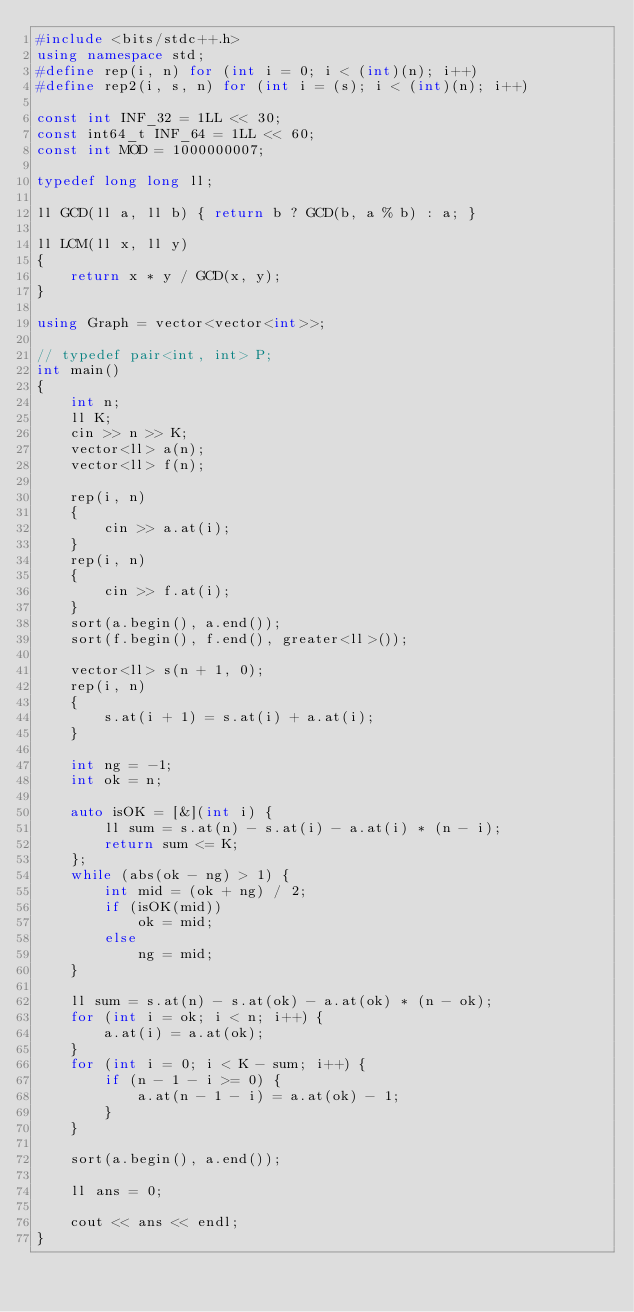Convert code to text. <code><loc_0><loc_0><loc_500><loc_500><_C++_>#include <bits/stdc++.h>
using namespace std;
#define rep(i, n) for (int i = 0; i < (int)(n); i++)
#define rep2(i, s, n) for (int i = (s); i < (int)(n); i++)

const int INF_32 = 1LL << 30;
const int64_t INF_64 = 1LL << 60;
const int MOD = 1000000007;

typedef long long ll;

ll GCD(ll a, ll b) { return b ? GCD(b, a % b) : a; }

ll LCM(ll x, ll y)
{
    return x * y / GCD(x, y);
}

using Graph = vector<vector<int>>;

// typedef pair<int, int> P;
int main()
{
    int n;
    ll K;
    cin >> n >> K;
    vector<ll> a(n);
    vector<ll> f(n);

    rep(i, n)
    {
        cin >> a.at(i);
    }
    rep(i, n)
    {
        cin >> f.at(i);
    }
    sort(a.begin(), a.end());
    sort(f.begin(), f.end(), greater<ll>());

    vector<ll> s(n + 1, 0);
    rep(i, n)
    {
        s.at(i + 1) = s.at(i) + a.at(i);
    }

    int ng = -1;
    int ok = n;

    auto isOK = [&](int i) {
        ll sum = s.at(n) - s.at(i) - a.at(i) * (n - i);
        return sum <= K;
    };
    while (abs(ok - ng) > 1) {
        int mid = (ok + ng) / 2;
        if (isOK(mid))
            ok = mid;
        else
            ng = mid;
    }

    ll sum = s.at(n) - s.at(ok) - a.at(ok) * (n - ok);
    for (int i = ok; i < n; i++) {
        a.at(i) = a.at(ok);
    }
    for (int i = 0; i < K - sum; i++) {
        if (n - 1 - i >= 0) {
            a.at(n - 1 - i) = a.at(ok) - 1;
        }
    }

    sort(a.begin(), a.end());

    ll ans = 0;

    cout << ans << endl;
}</code> 